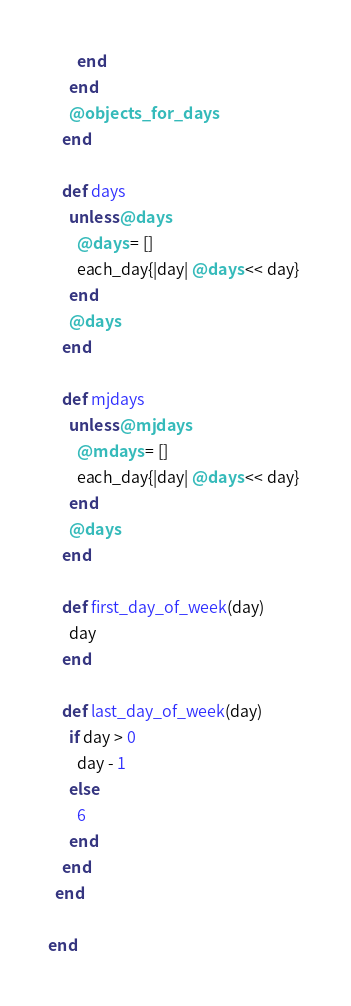Convert code to text. <code><loc_0><loc_0><loc_500><loc_500><_Ruby_>        end
      end
      @objects_for_days
    end
    
    def days
      unless @days
        @days = []
        each_day{|day| @days << day} 
      end
      @days     
    end    
    
    def mjdays
      unless @mjdays
        @mdays = []
        each_day{|day| @days << day} 
      end
      @days     
    end    
    
    def first_day_of_week(day)
      day
    end
    
    def last_day_of_week(day)
      if day > 0
        day - 1
      else
        6
      end
    end    
  end

end
</code> 